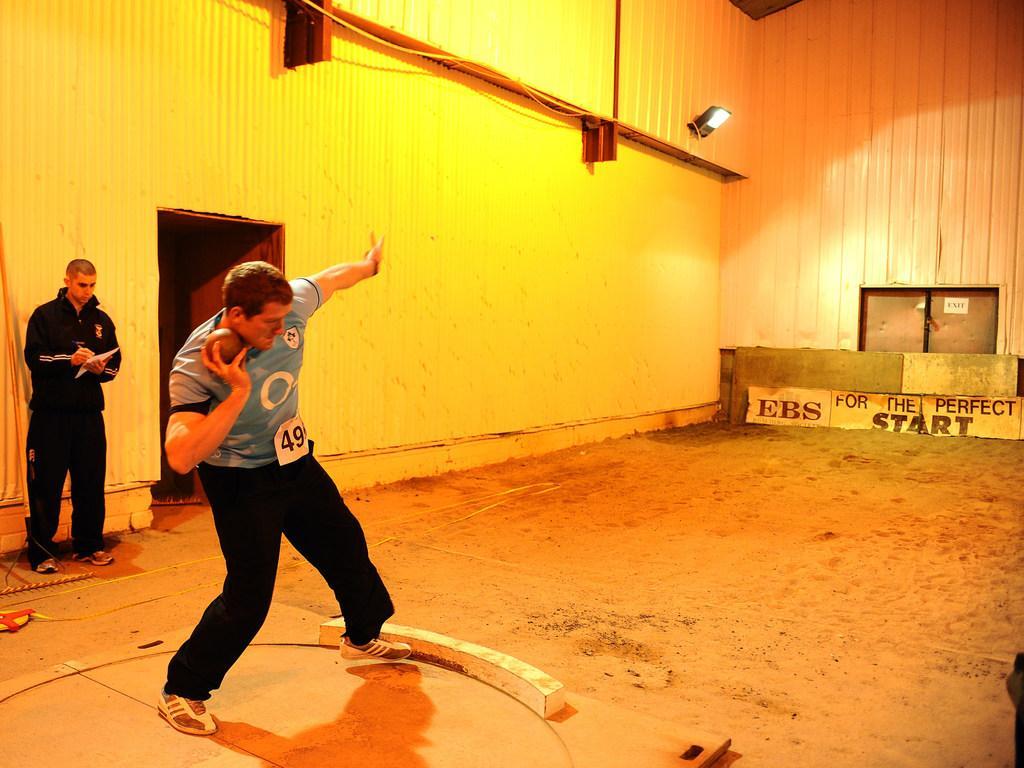In one or two sentences, can you explain what this image depicts? In this image we can see a person is throwing a shot put and another person is standing and holding a paper in his hand. 